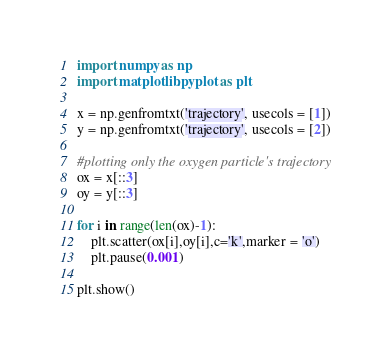<code> <loc_0><loc_0><loc_500><loc_500><_Python_>import numpy as np
import matplotlib.pyplot as plt

x = np.genfromtxt('trajectory', usecols = [1])
y = np.genfromtxt('trajectory', usecols = [2])

#plotting only the oxygen particle's trajectory
ox = x[::3]
oy = y[::3]

for i in range(len(ox)-1):
    plt.scatter(ox[i],oy[i],c='k',marker = 'o')
    plt.pause(0.001)

plt.show()</code> 